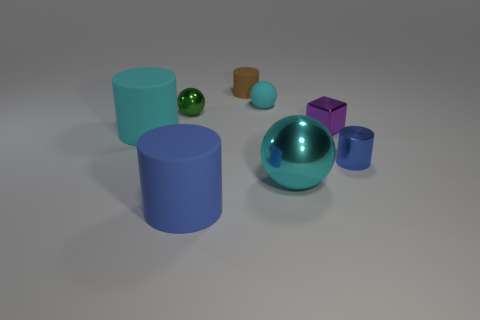Subtract all small green spheres. How many spheres are left? 2 Subtract all green balls. How many balls are left? 2 Add 1 small cyan objects. How many objects exist? 9 Subtract all purple cylinders. How many cyan spheres are left? 2 Subtract all spheres. How many objects are left? 5 Subtract 1 balls. How many balls are left? 2 Subtract all metallic things. Subtract all big cyan things. How many objects are left? 2 Add 7 tiny purple metal things. How many tiny purple metal things are left? 8 Add 8 big green metal cubes. How many big green metal cubes exist? 8 Subtract 0 red cylinders. How many objects are left? 8 